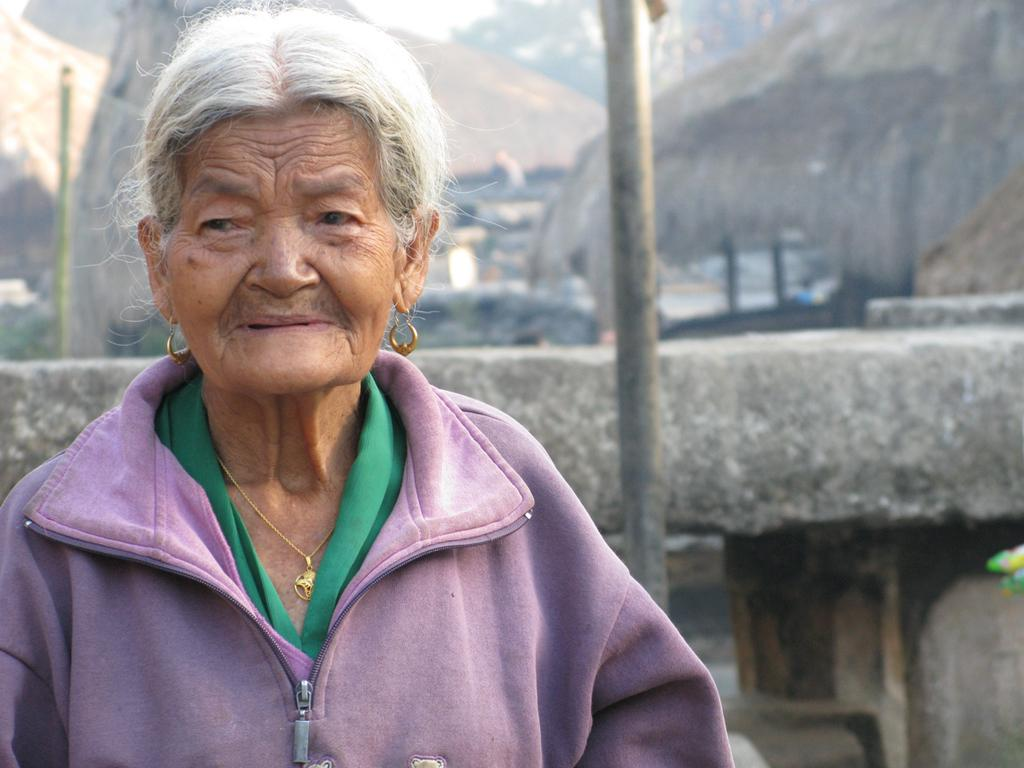Who is the main subject in the image? There is an old woman in the image. What is the old woman wearing? The old woman is wearing a violet dress. What can be seen behind the old woman? There is a stone wall behind the old woman. What else is visible in the background of the image? There are other objects in the background of the image. What is the old woman's opinion on pollution in the image? There is no information about the old woman's opinion on pollution in the image. 